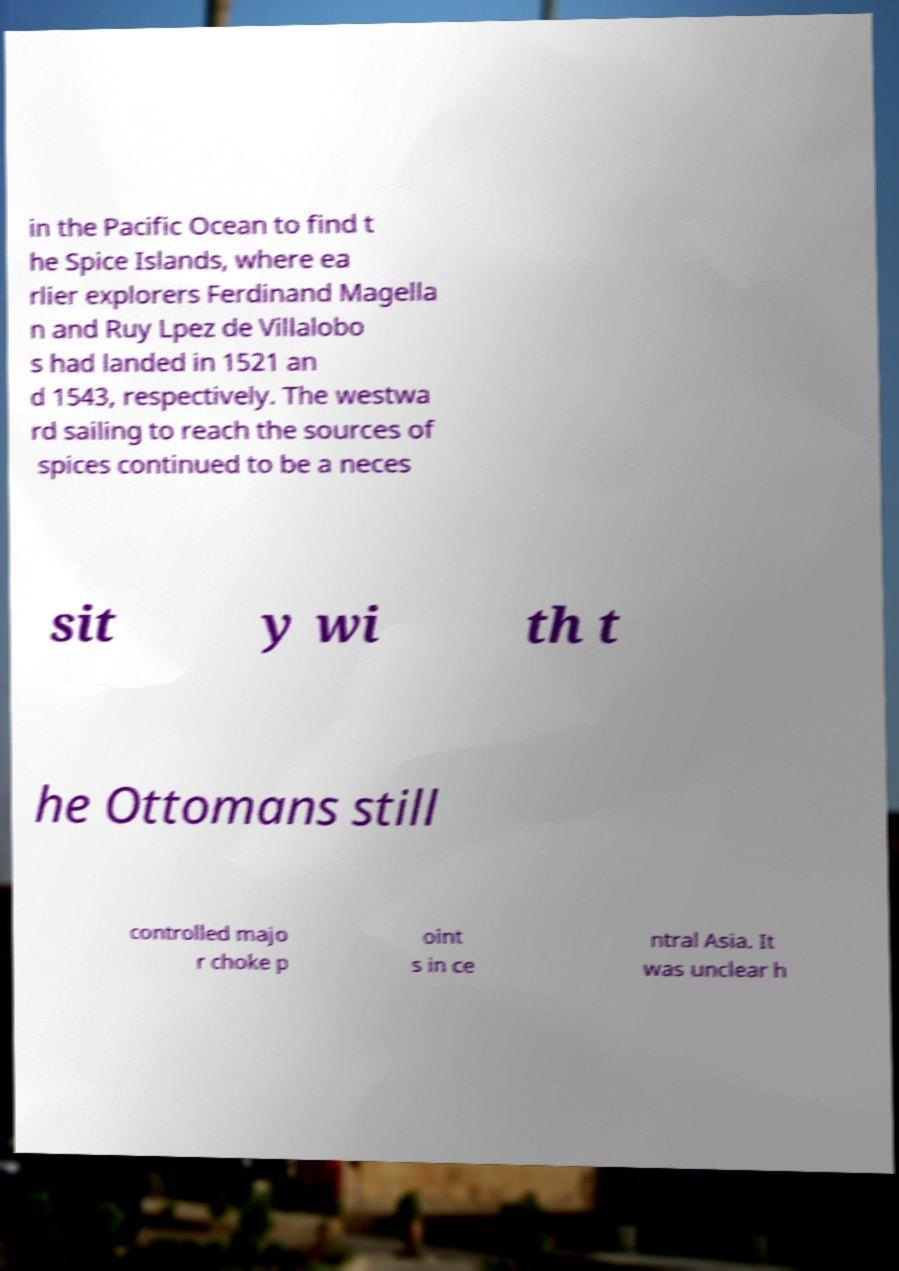Please identify and transcribe the text found in this image. in the Pacific Ocean to find t he Spice Islands, where ea rlier explorers Ferdinand Magella n and Ruy Lpez de Villalobo s had landed in 1521 an d 1543, respectively. The westwa rd sailing to reach the sources of spices continued to be a neces sit y wi th t he Ottomans still controlled majo r choke p oint s in ce ntral Asia. It was unclear h 